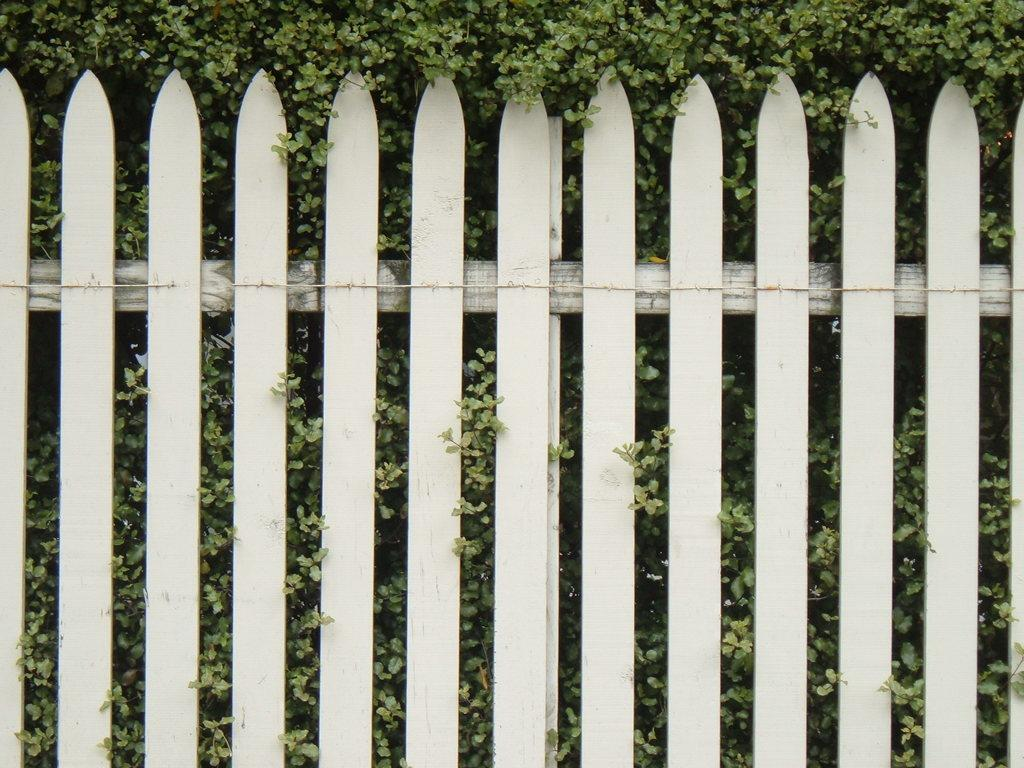What can be seen in the image that separates different areas? There is a fence in the image. What is located behind the fence in the image? There are plants behind the fence. What type of winter clothing is being worn by the plants in the image? There is no winter clothing present in the image, as the subjects are plants and not people. 